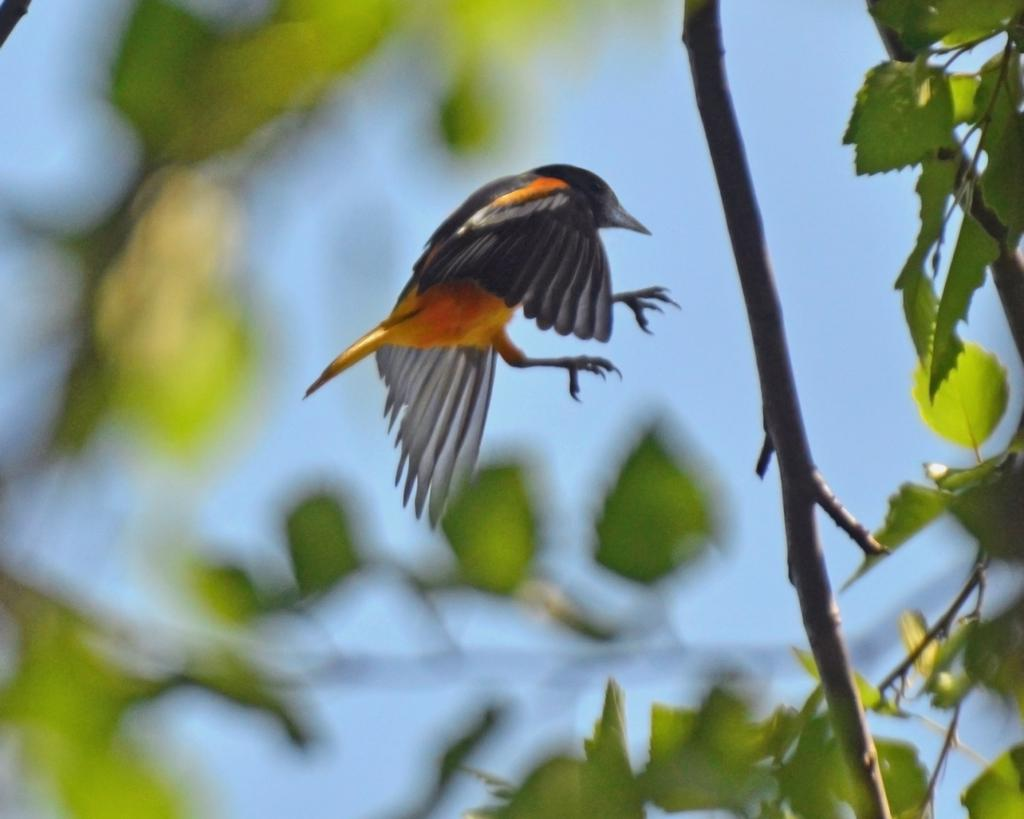What is flying in the sky in the image? There is a bird in the sky in the image. What can be seen in the foreground of the image? There is a tree in the foreground of the image. What type of fruit is hanging from the branches of the tree in the image? There is no fruit visible on the tree in the image. Can you describe the position of the zebra in the image? There is no zebra present in the image. 